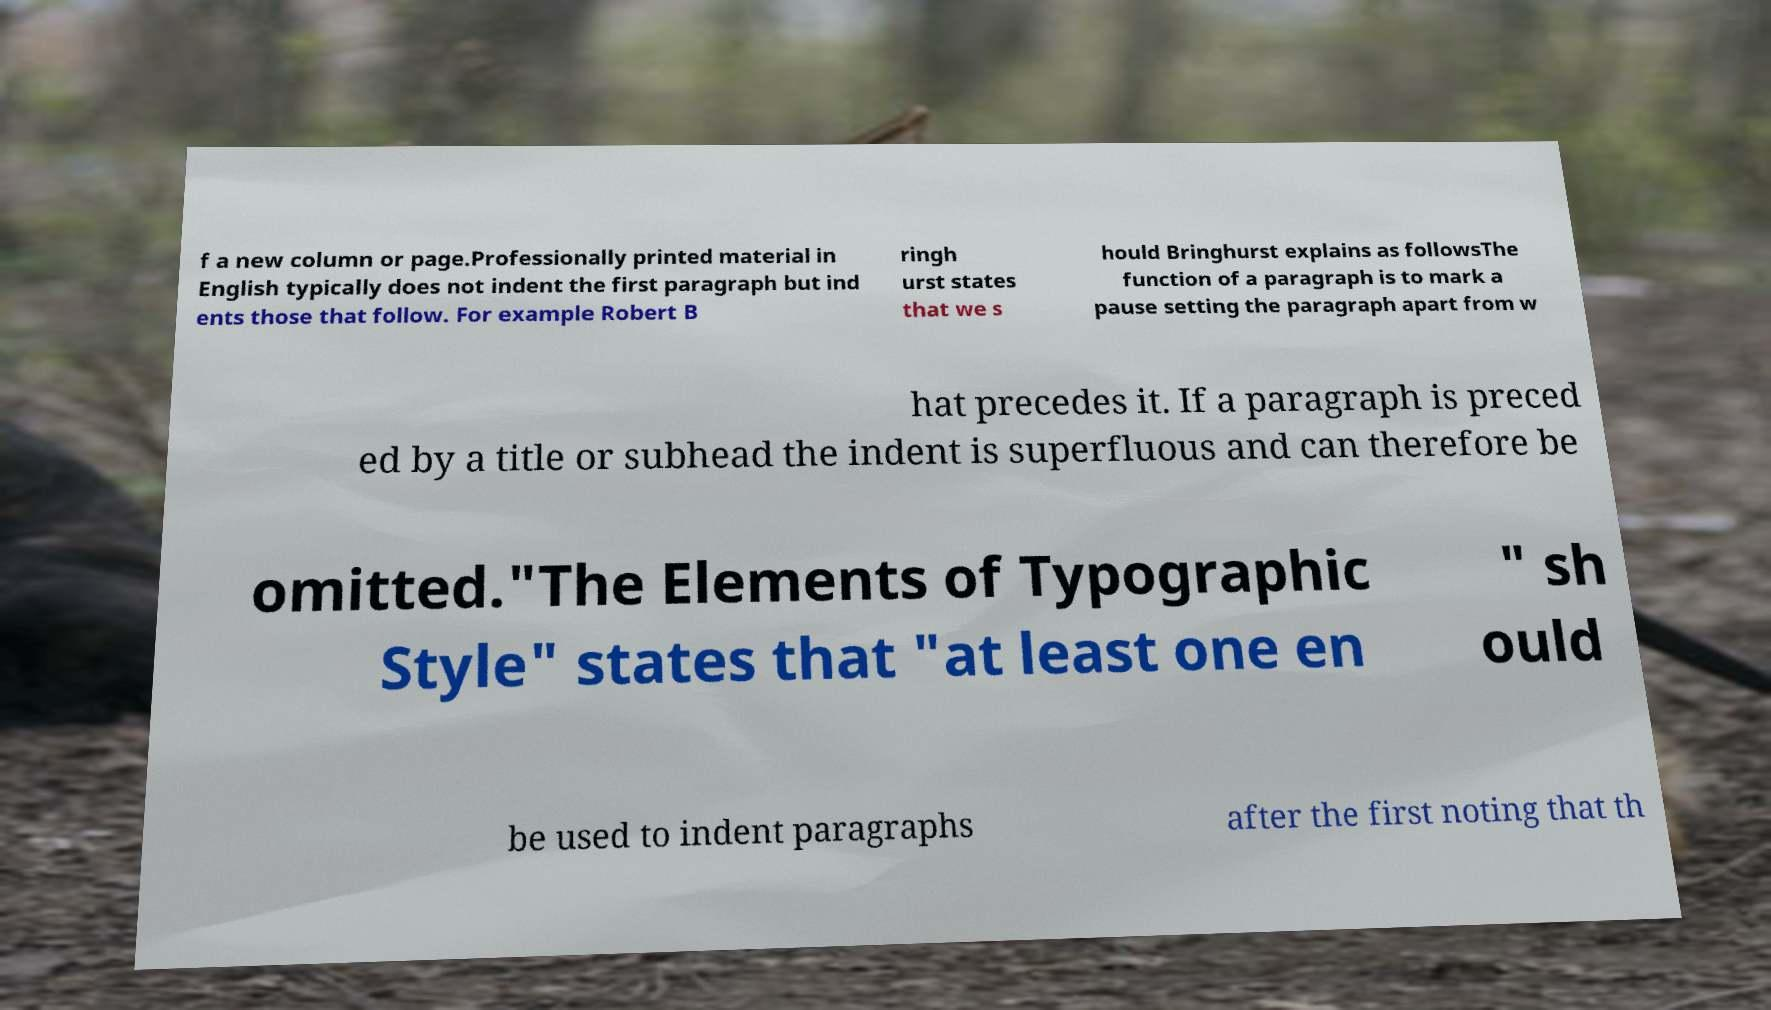For documentation purposes, I need the text within this image transcribed. Could you provide that? f a new column or page.Professionally printed material in English typically does not indent the first paragraph but ind ents those that follow. For example Robert B ringh urst states that we s hould Bringhurst explains as followsThe function of a paragraph is to mark a pause setting the paragraph apart from w hat precedes it. If a paragraph is preced ed by a title or subhead the indent is superfluous and can therefore be omitted."The Elements of Typographic Style" states that "at least one en " sh ould be used to indent paragraphs after the first noting that th 